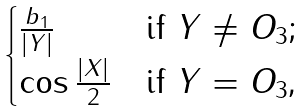Convert formula to latex. <formula><loc_0><loc_0><loc_500><loc_500>\begin{cases} \frac { b _ { 1 } } { \left | Y \right | } & \text {if $Y \neq O_{3}$;} \\ \cos \frac { \left | X \right | } { 2 } & \text {if $Y= O_{3}$,} \\ \end{cases}</formula> 